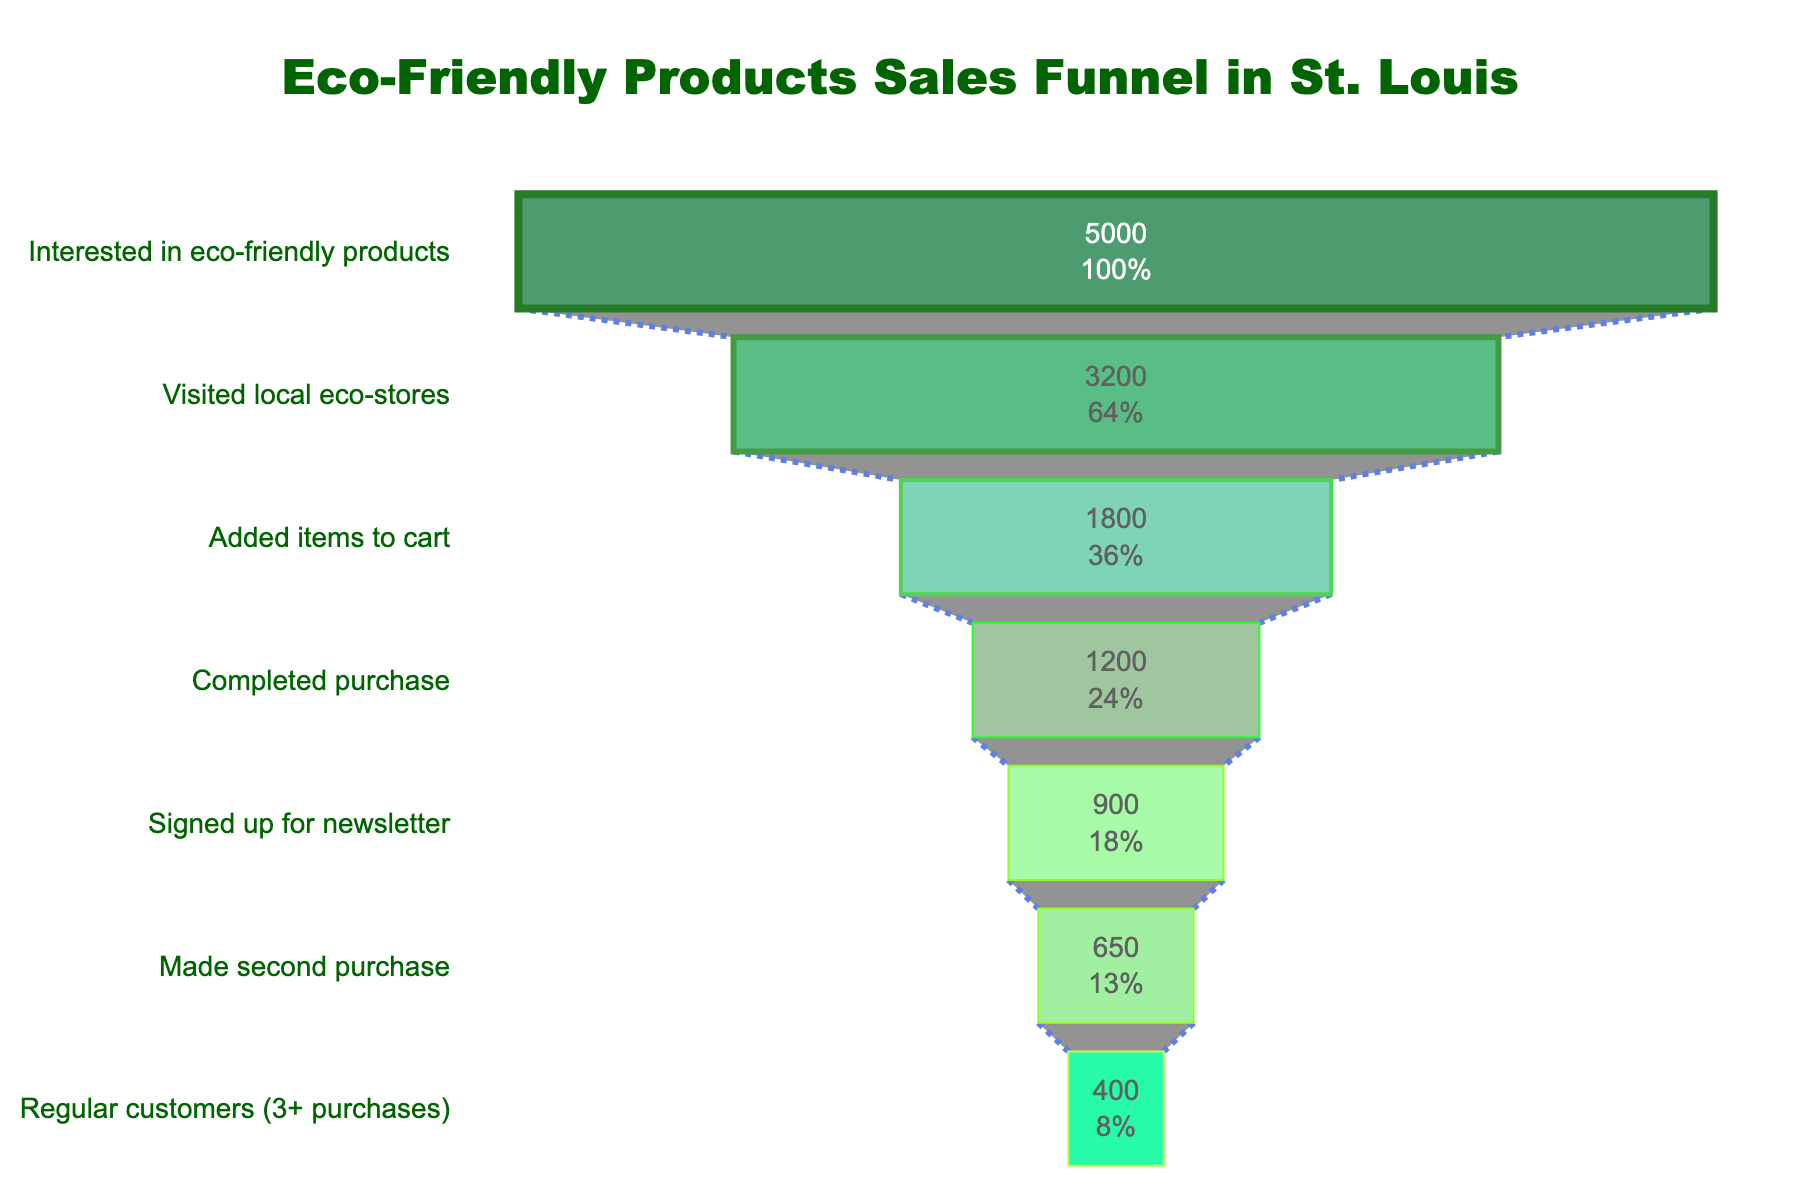What's the title of the funnel chart? The title is bold and positioned at the center top of the chart. It is usually a descriptive phrase that summarizes the content of the funnel. In this case, the title is "Eco-Friendly Products Sales Funnel in St. Louis".
Answer: Eco-Friendly Products Sales Funnel in St. Louis How many stages are there in the sales funnel? By counting the distinct stages listed on the y-axis of the funnel chart, we can determine the number of stages. There are 7 stages: Interested in eco-friendly products, Visited local eco-stores, Added items to cart, Completed purchase, Signed up for newsletter, Made second purchase, and Regular customers (3+ purchases).
Answer: 7 What percentage of interested customers visited local eco-stores? The figure indicates the initial percentage representation at each stage. By looking at the value inside the funnel for "Visited local eco-stores", it shows both the count (3200) and the percentage relative to the initial count (5000).
Answer: 64% How many customers added items to the cart? The funnel stage labeled "Added items to cart" shows the count of customers at this stage, available directly from the figure.
Answer: 1800 What stage has the highest drop-off compared to the previous stage? To find the highest drop-off stage, compute the difference between the customer counts of each consecutive stage. The stage with the largest difference indicates the highest drop-off.
Answer: Visited local eco-stores By how much does the number of customers decrease from "Completed purchase" to "Signed up for newsletter"? Subtract the count of customers who signed up for the newsletter from those who completed a purchase. 1200 (Completed purchase) - 900 (Signed up for newsletter) = 300.
Answer: 300 What's the percentage increase from second purchase to becoming regular customers? To get the percentage increase, calculate ((Regular customers - Made second purchase) / Made second purchase) * 100. Using the values: ((400 - 650) / 650) * 100 = -38.46%. Since it’s a decrease, not an increase, it represents a drop.
Answer: -38.46% How many regular customers are there? The funnel displays the number of regular customers directly in the stage labeled "Regular customers (3+ purchases)".
Answer: 400 Which stage conversion has the smallest percentage reduction to the next stage? To determine this, compute the reduction percentage between each stage and find the smallest value. Here, the smallest percentage reduction is from "Signed up for newsletter" to "Made second purchase".(750-650)/750 = 13.3%
Answer: Signed up for newsletter to Made second purchase How does the final stage compare to the initial number of interested customers in terms of repeat purchase percentage? Divide the count of regular customers by the initial count of interested customers and multiply by 100. (400 / 5000) * 100 = 8%. This tells us that 8% of initially interested customers become regular customers.
Answer: 8% 